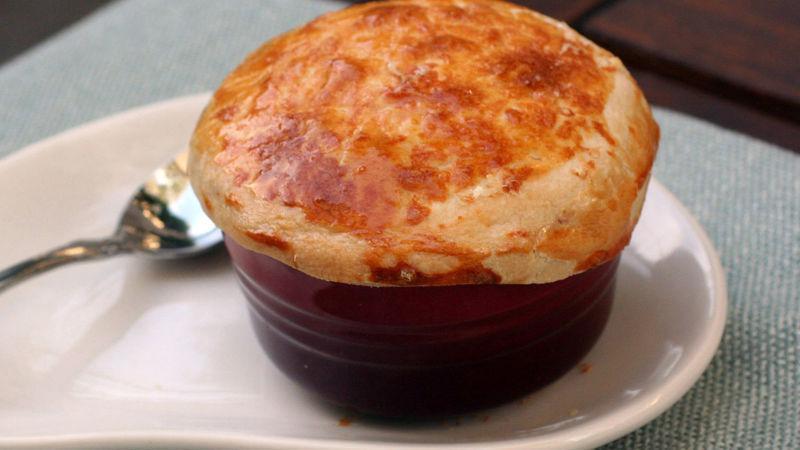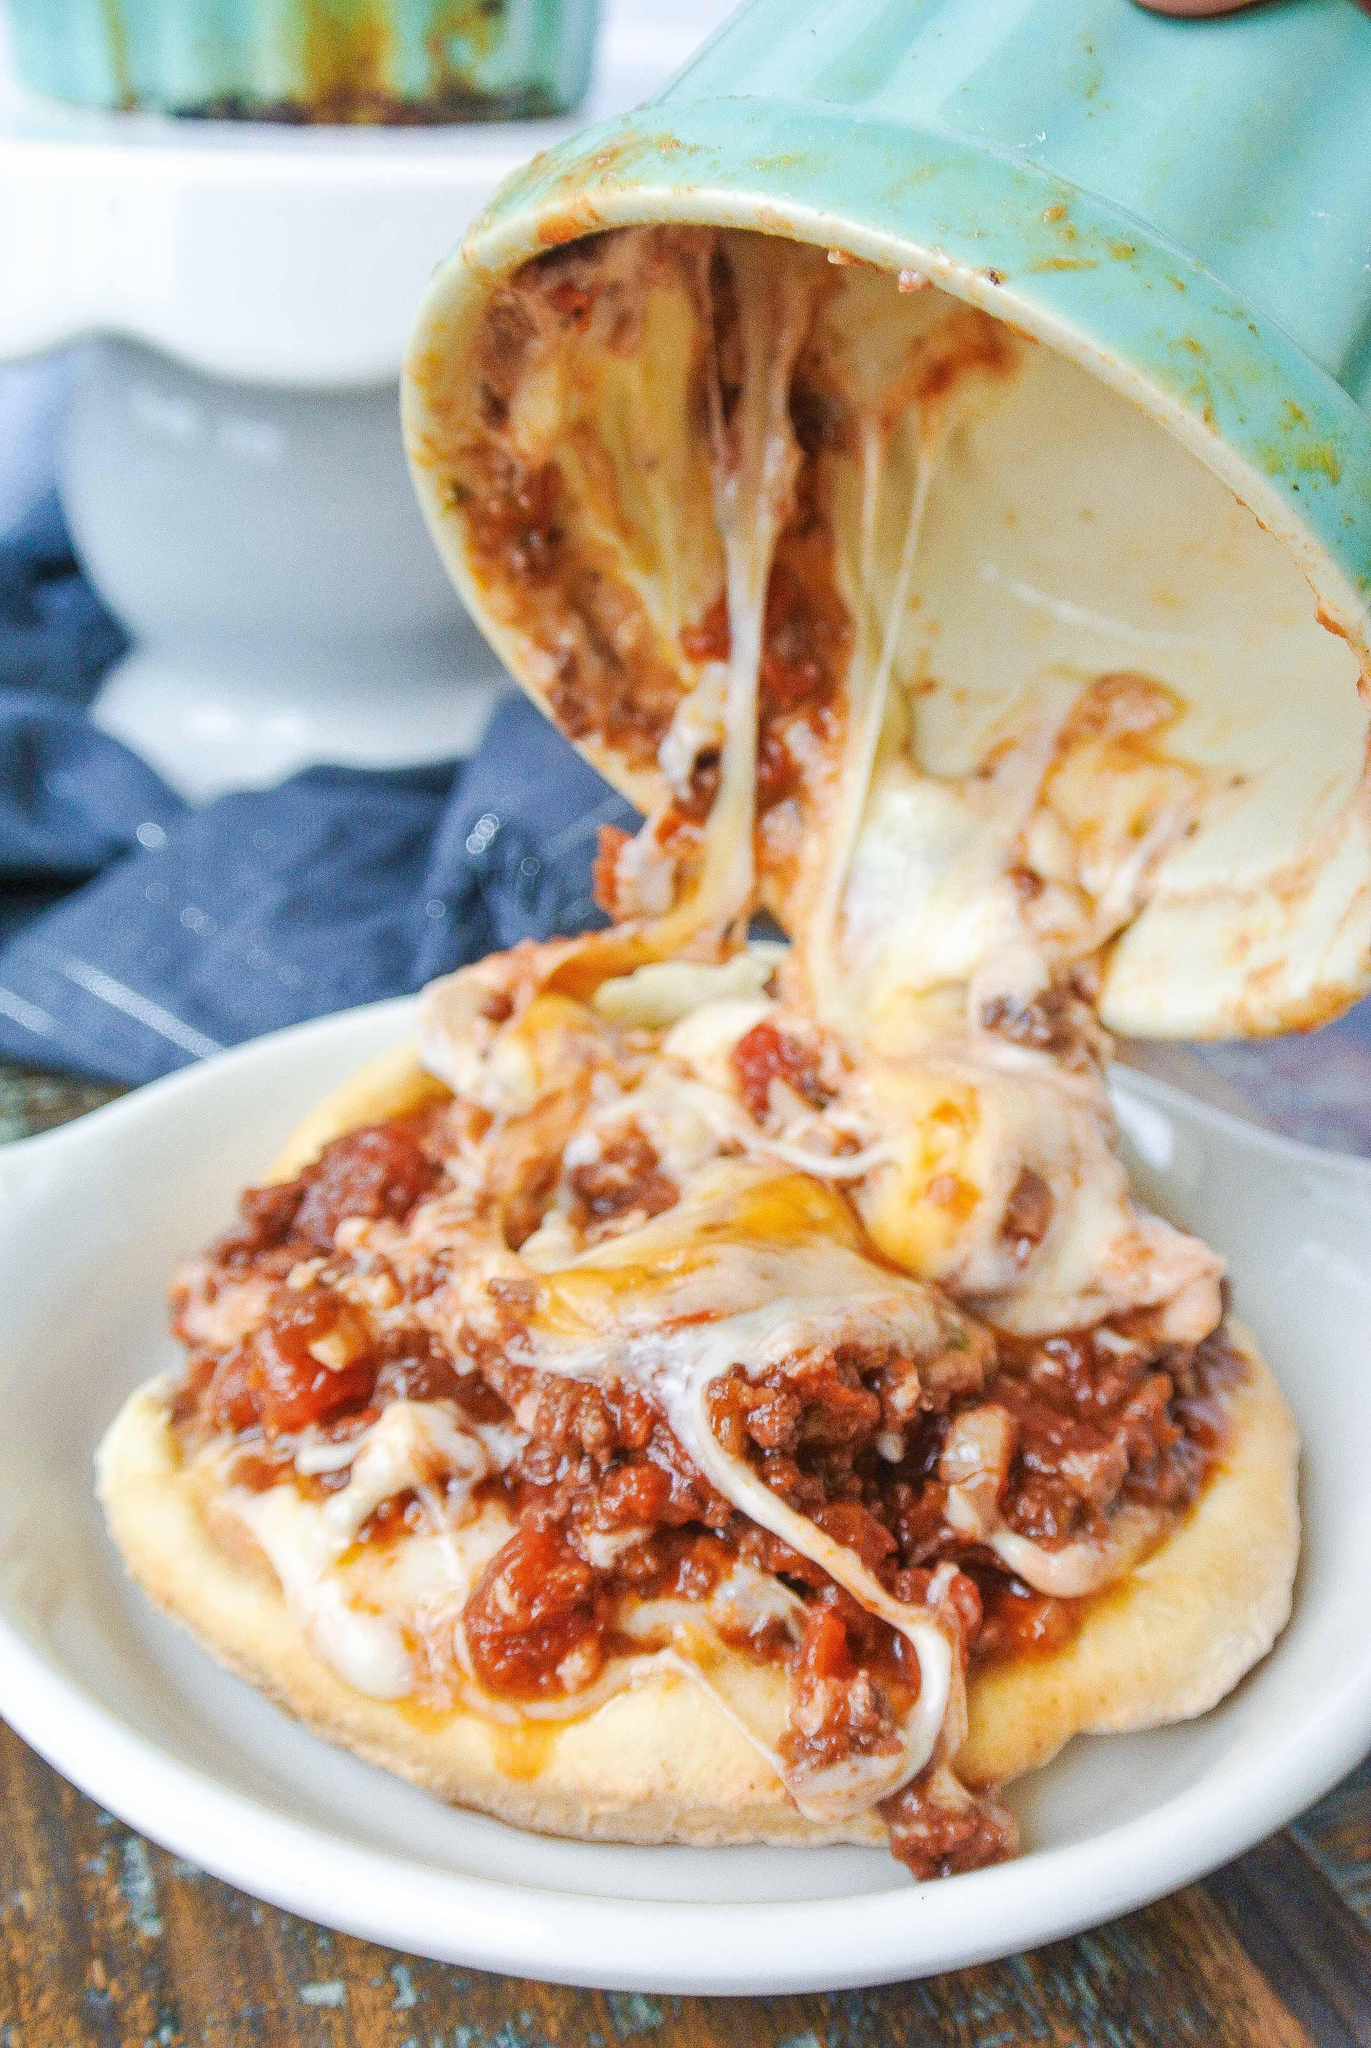The first image is the image on the left, the second image is the image on the right. Examine the images to the left and right. Is the description "One image shows a fork above a single-serve round pizza with a rolled crust edge, and cheese is stretching from the fork to the pizza." accurate? Answer yes or no. No. 